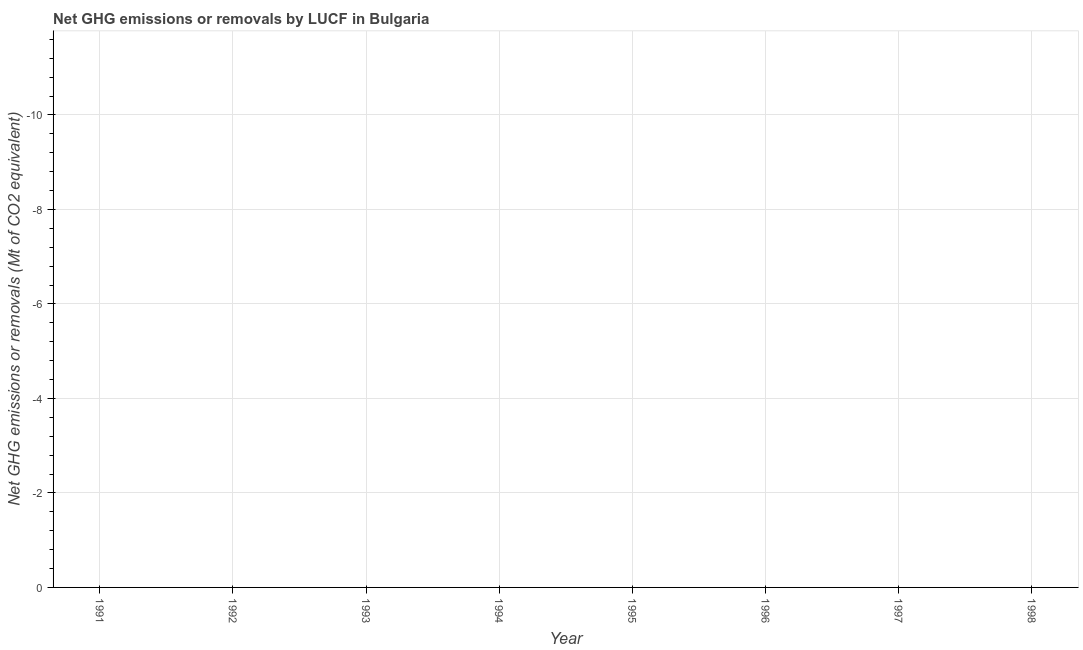What is the ghg net emissions or removals in 1997?
Make the answer very short. 0. What is the median ghg net emissions or removals?
Make the answer very short. 0. Does the graph contain any zero values?
Your answer should be very brief. Yes. What is the title of the graph?
Provide a succinct answer. Net GHG emissions or removals by LUCF in Bulgaria. What is the label or title of the Y-axis?
Your response must be concise. Net GHG emissions or removals (Mt of CO2 equivalent). What is the Net GHG emissions or removals (Mt of CO2 equivalent) of 1994?
Offer a very short reply. 0. 